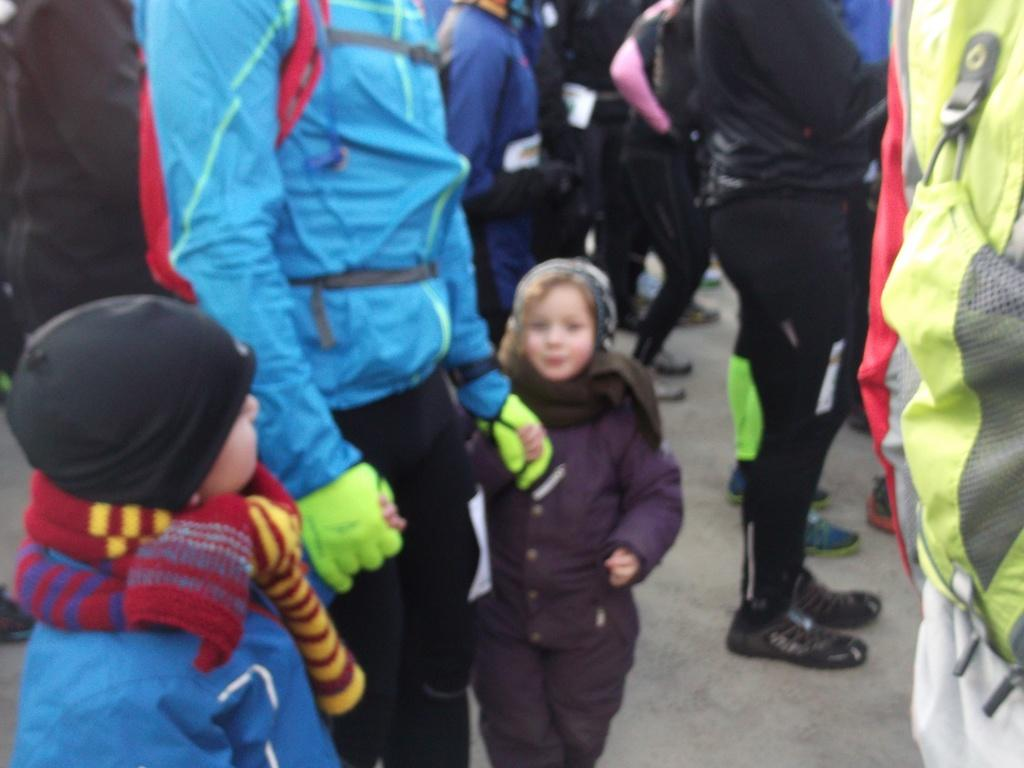How many people are in the image? There are many people standing in the image. What are the people wearing? The people are wearing clothes. Can you describe any accessories visible in the image? Yes, there is a cap and a scarf visible in the image. What type of path can be seen in the image? There is a footpath in the image. What type of footwear is visible in the image? There are shoes visible in the image. What is the man carrying on his back? A man is carrying a bag on his back. What type of breakfast is being served on the yoke in the image? There is no yoke or breakfast present in the image. 